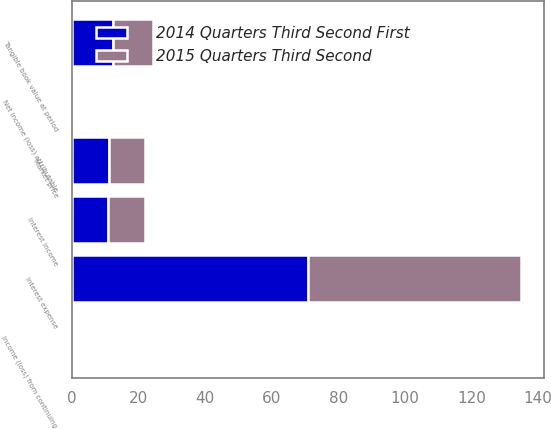<chart> <loc_0><loc_0><loc_500><loc_500><stacked_bar_chart><ecel><fcel>Interest income<fcel>Interest expense<fcel>Income (loss) from continuing<fcel>Net income (loss) attributable<fcel>Tangible book value at period<fcel>Market price<nl><fcel>2014 Quarters Third Second First<fcel>10.935<fcel>71<fcel>0.27<fcel>0.27<fcel>12.51<fcel>11.22<nl><fcel>2015 Quarters Third Second<fcel>10.935<fcel>64<fcel>0.28<fcel>0.29<fcel>11.91<fcel>10.65<nl></chart> 